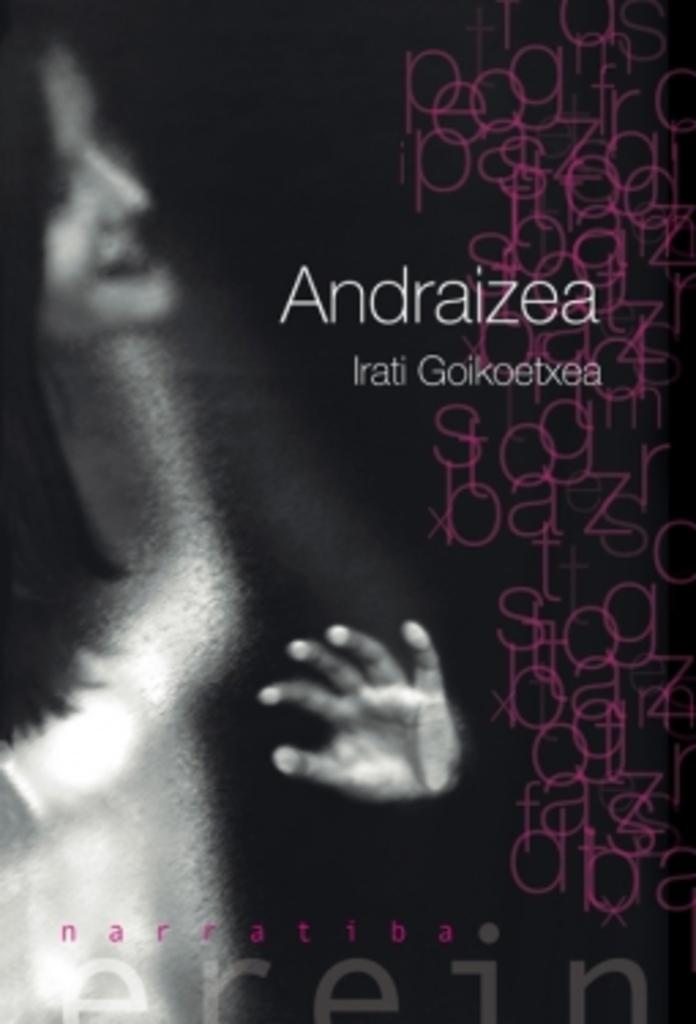<image>
Share a concise interpretation of the image provided. A poster  with a woman and purples letters all over it advertising Andraizea. 